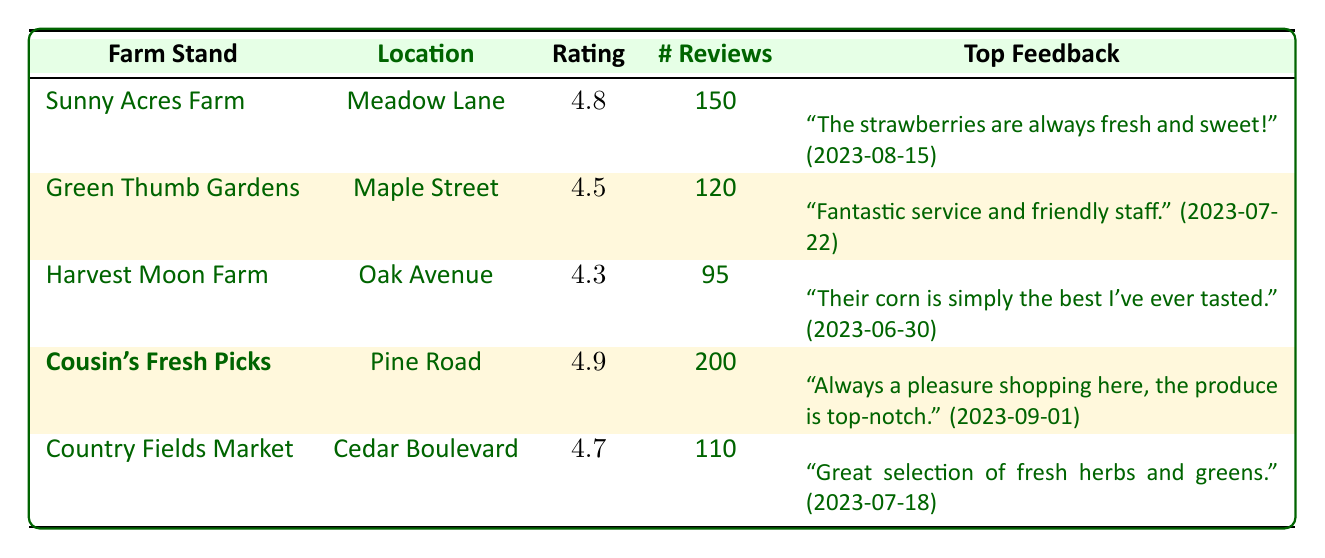What is the rating of Cousin's Fresh Picks? The rating for Cousin's Fresh Picks is listed in the table under the Rating column. It shows a rating of 4.9.
Answer: 4.9 How many reviews does Green Thumb Gardens have? The number of reviews for Green Thumb Gardens is provided under the # Reviews column. It shows a total of 120 reviews.
Answer: 120 Which farm stand has the highest rating? To identify the highest rating, we compare the ratings in the Rating column. Cousin's Fresh Picks has the highest rating at 4.9.
Answer: Cousin's Fresh Picks What is the average rating of all the farm stands listed? The ratings are 4.8, 4.5, 4.3, 4.9, and 4.7. Summing them gives 24.2. Dividing this by the number of farm stands (5) gives an average rating of 4.84.
Answer: 4.84 Does Harvest Moon Farm have more reviews than Country Fields Market? Harvest Moon Farm has 95 reviews and Country Fields Market has 110 reviews. Since 95 is less than 110, the answer is no.
Answer: No What feedback was noted for the farm stand with the second-highest rating? The second-highest rating is 4.8, which belongs to Sunny Acres Farm. The top feedback noted is "The strawberries are always fresh and sweet!" dated 2023-08-15.
Answer: "The strawberries are always fresh and sweet!" (2023-08-15) How many total reviews do all the farm stands have combined? We sum the number of reviews from each farm stand: 150 (Sunny Acres) + 120 (Green Thumb) + 95 (Harvest Moon) + 200 (Cousin's Fresh Picks) + 110 (Country Fields) = 775 total reviews.
Answer: 775 Is there a farm stand that has both a rating above 4.5 and more than 150 reviews? Cousin's Fresh Picks has a rating of 4.9 and 200 reviews, meeting both conditions. Therefore, the answer is yes.
Answer: Yes What is the feedback date for the best-rated farm stand's top feedback? Cousin's Fresh Picks has a rating of 4.9, and its top feedback is "Always a pleasure shopping here, the produce is top-notch." dated 2023-09-01.
Answer: 2023-09-01 